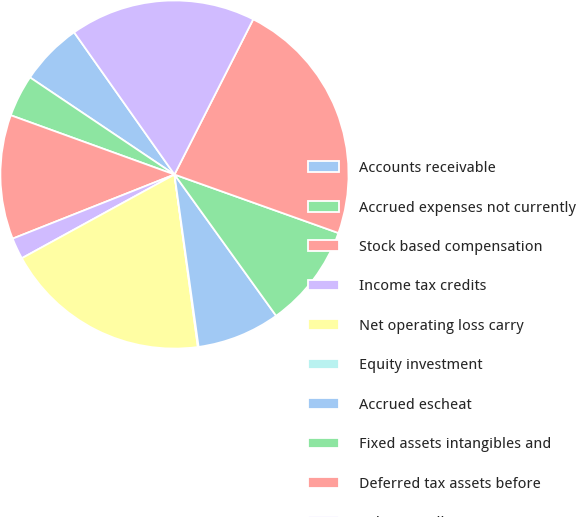<chart> <loc_0><loc_0><loc_500><loc_500><pie_chart><fcel>Accounts receivable<fcel>Accrued expenses not currently<fcel>Stock based compensation<fcel>Income tax credits<fcel>Net operating loss carry<fcel>Equity investment<fcel>Accrued escheat<fcel>Fixed assets intangibles and<fcel>Deferred tax assets before<fcel>Valuation allowance<nl><fcel>5.8%<fcel>3.89%<fcel>11.53%<fcel>1.98%<fcel>19.16%<fcel>0.07%<fcel>7.71%<fcel>9.62%<fcel>22.98%<fcel>17.25%<nl></chart> 